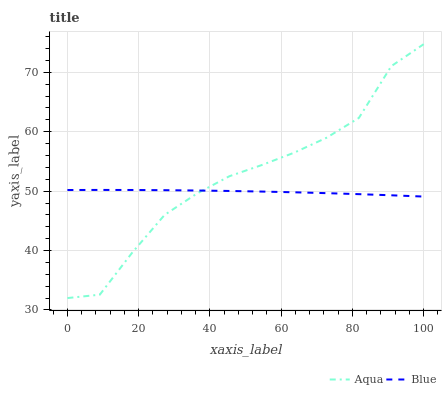Does Blue have the minimum area under the curve?
Answer yes or no. Yes. Does Aqua have the maximum area under the curve?
Answer yes or no. Yes. Does Aqua have the minimum area under the curve?
Answer yes or no. No. Is Blue the smoothest?
Answer yes or no. Yes. Is Aqua the roughest?
Answer yes or no. Yes. Is Aqua the smoothest?
Answer yes or no. No. 